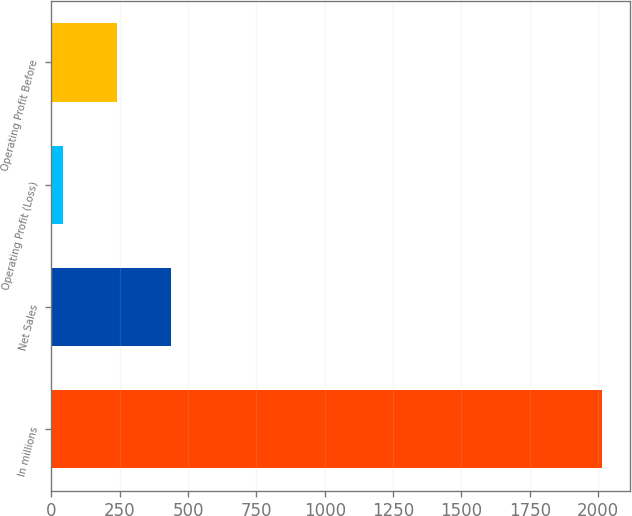Convert chart. <chart><loc_0><loc_0><loc_500><loc_500><bar_chart><fcel>In millions<fcel>Net Sales<fcel>Operating Profit (Loss)<fcel>Operating Profit Before<nl><fcel>2016<fcel>437.6<fcel>43<fcel>240.3<nl></chart> 